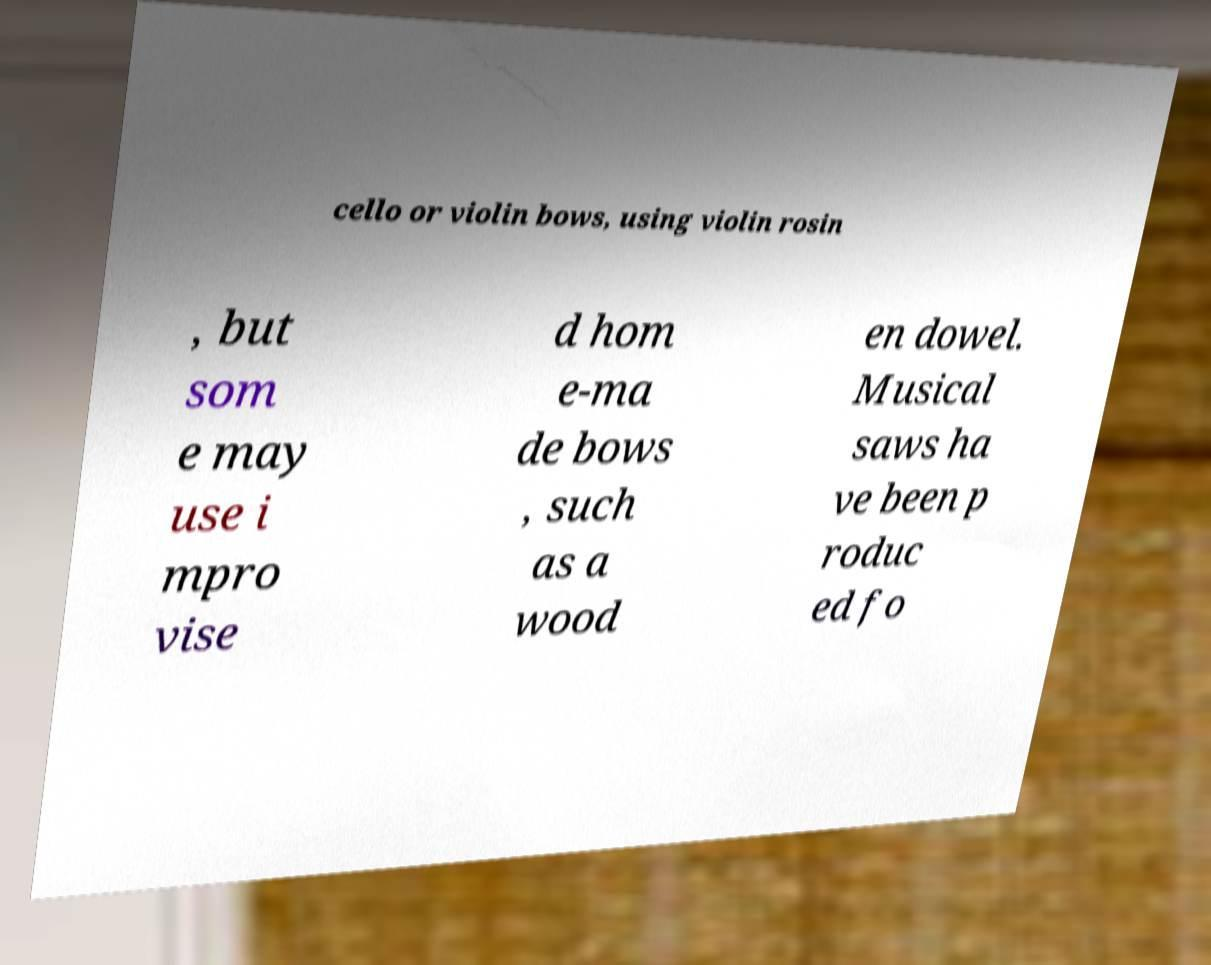Could you assist in decoding the text presented in this image and type it out clearly? cello or violin bows, using violin rosin , but som e may use i mpro vise d hom e-ma de bows , such as a wood en dowel. Musical saws ha ve been p roduc ed fo 